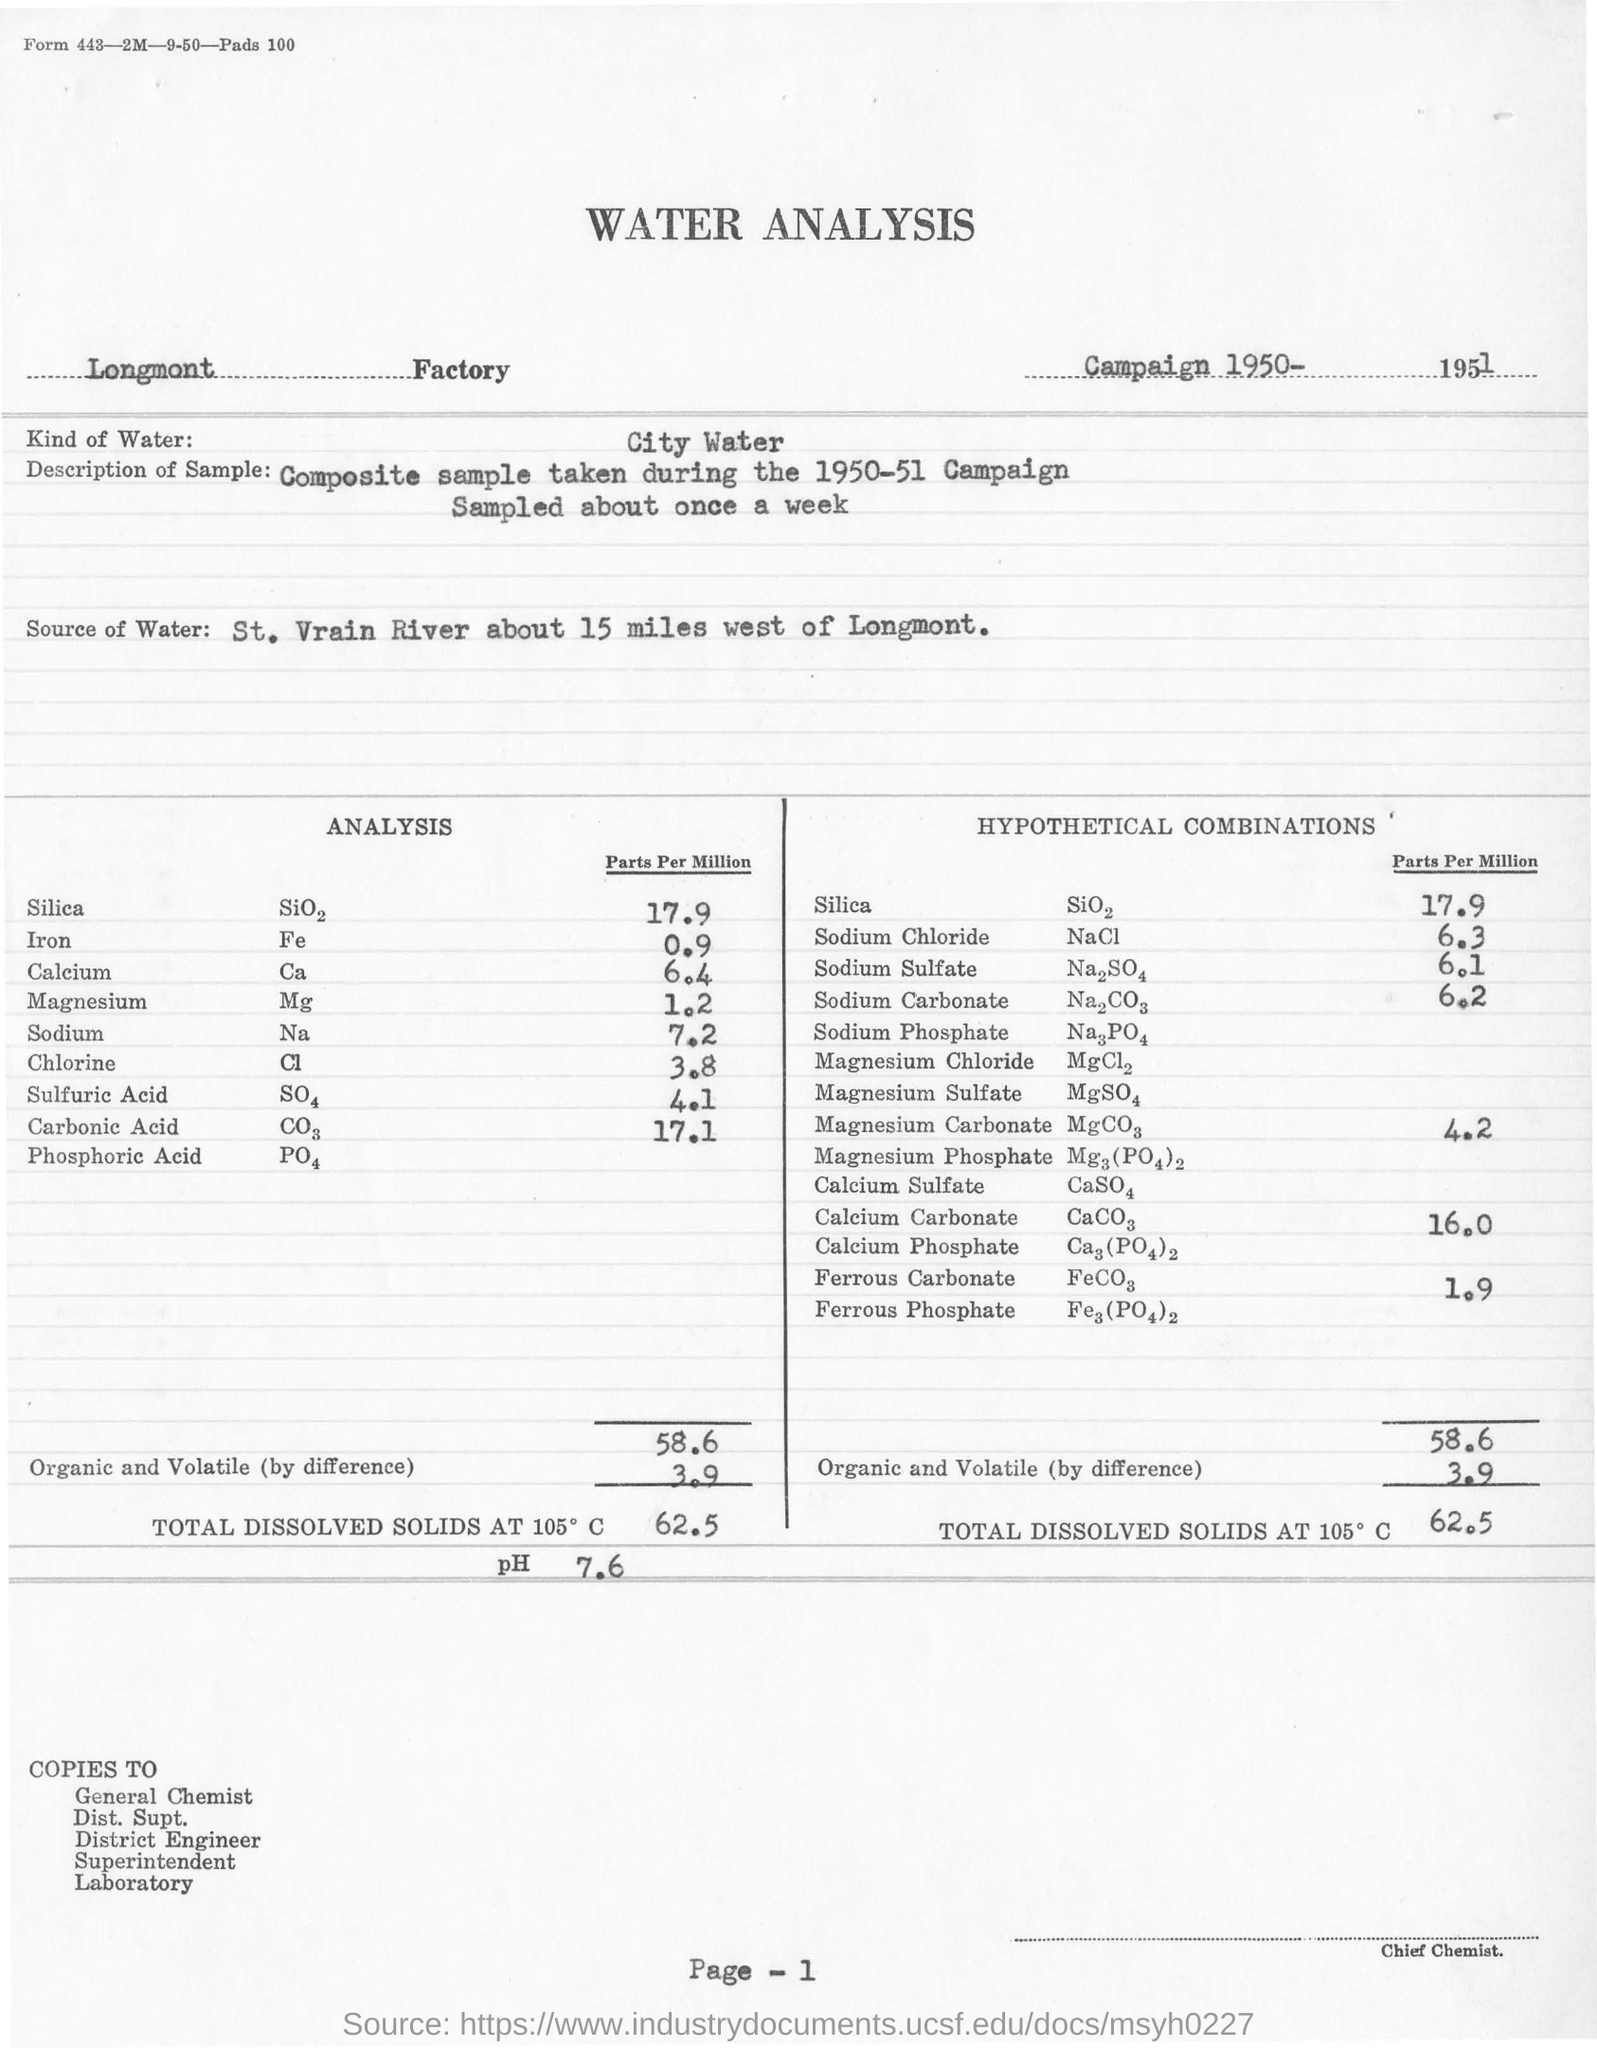In which factory was the water analysis carried out?
Provide a succinct answer. Longmont. What was the kind of water analysed?
Make the answer very short. City Water. Which river was the source of water?
Your answer should be very brief. St. Vrain River. In which year did the Campaign take place?
Offer a terse response. 1950-51. What was the pH ?
Provide a succinct answer. 7.6. 